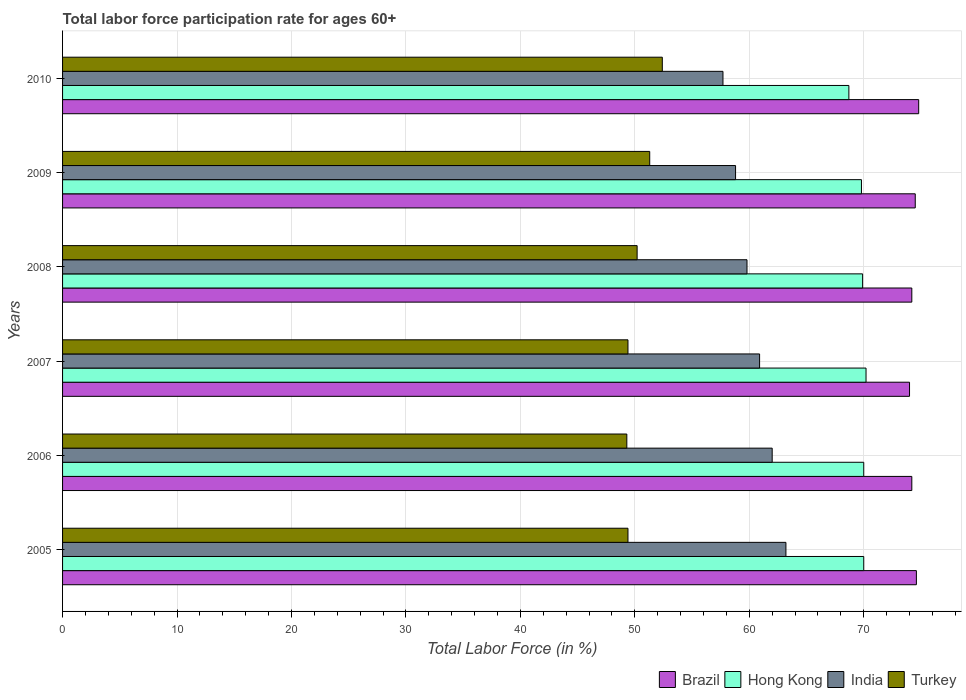How many groups of bars are there?
Your answer should be very brief. 6. Are the number of bars per tick equal to the number of legend labels?
Provide a short and direct response. Yes. Are the number of bars on each tick of the Y-axis equal?
Keep it short and to the point. Yes. How many bars are there on the 3rd tick from the top?
Provide a succinct answer. 4. How many bars are there on the 2nd tick from the bottom?
Ensure brevity in your answer.  4. What is the label of the 6th group of bars from the top?
Provide a short and direct response. 2005. In how many cases, is the number of bars for a given year not equal to the number of legend labels?
Your response must be concise. 0. What is the labor force participation rate in Brazil in 2005?
Your answer should be very brief. 74.6. Across all years, what is the maximum labor force participation rate in Hong Kong?
Offer a very short reply. 70.2. Across all years, what is the minimum labor force participation rate in Turkey?
Your answer should be compact. 49.3. What is the total labor force participation rate in Hong Kong in the graph?
Keep it short and to the point. 418.6. What is the difference between the labor force participation rate in India in 2005 and that in 2006?
Offer a very short reply. 1.2. What is the difference between the labor force participation rate in Turkey in 2008 and the labor force participation rate in Brazil in 2007?
Your answer should be compact. -23.8. What is the average labor force participation rate in Turkey per year?
Provide a succinct answer. 50.33. In the year 2005, what is the difference between the labor force participation rate in Brazil and labor force participation rate in India?
Give a very brief answer. 11.4. In how many years, is the labor force participation rate in India greater than 64 %?
Your answer should be very brief. 0. What is the ratio of the labor force participation rate in Turkey in 2009 to that in 2010?
Offer a very short reply. 0.98. What is the difference between the highest and the second highest labor force participation rate in Hong Kong?
Ensure brevity in your answer.  0.2. In how many years, is the labor force participation rate in Brazil greater than the average labor force participation rate in Brazil taken over all years?
Make the answer very short. 3. What does the 2nd bar from the top in 2009 represents?
Offer a very short reply. India. What does the 4th bar from the bottom in 2005 represents?
Your response must be concise. Turkey. Is it the case that in every year, the sum of the labor force participation rate in Brazil and labor force participation rate in Turkey is greater than the labor force participation rate in Hong Kong?
Your answer should be very brief. Yes. How many bars are there?
Offer a very short reply. 24. Are all the bars in the graph horizontal?
Offer a very short reply. Yes. Does the graph contain any zero values?
Your response must be concise. No. Does the graph contain grids?
Your answer should be compact. Yes. What is the title of the graph?
Provide a succinct answer. Total labor force participation rate for ages 60+. Does "Nicaragua" appear as one of the legend labels in the graph?
Give a very brief answer. No. What is the Total Labor Force (in %) in Brazil in 2005?
Your answer should be compact. 74.6. What is the Total Labor Force (in %) of India in 2005?
Provide a succinct answer. 63.2. What is the Total Labor Force (in %) in Turkey in 2005?
Your answer should be very brief. 49.4. What is the Total Labor Force (in %) in Brazil in 2006?
Your answer should be compact. 74.2. What is the Total Labor Force (in %) of Turkey in 2006?
Offer a terse response. 49.3. What is the Total Labor Force (in %) of Brazil in 2007?
Give a very brief answer. 74. What is the Total Labor Force (in %) in Hong Kong in 2007?
Provide a succinct answer. 70.2. What is the Total Labor Force (in %) in India in 2007?
Offer a terse response. 60.9. What is the Total Labor Force (in %) of Turkey in 2007?
Your answer should be very brief. 49.4. What is the Total Labor Force (in %) in Brazil in 2008?
Ensure brevity in your answer.  74.2. What is the Total Labor Force (in %) in Hong Kong in 2008?
Provide a succinct answer. 69.9. What is the Total Labor Force (in %) of India in 2008?
Offer a terse response. 59.8. What is the Total Labor Force (in %) in Turkey in 2008?
Offer a very short reply. 50.2. What is the Total Labor Force (in %) in Brazil in 2009?
Make the answer very short. 74.5. What is the Total Labor Force (in %) of Hong Kong in 2009?
Provide a short and direct response. 69.8. What is the Total Labor Force (in %) in India in 2009?
Give a very brief answer. 58.8. What is the Total Labor Force (in %) of Turkey in 2009?
Offer a very short reply. 51.3. What is the Total Labor Force (in %) of Brazil in 2010?
Provide a succinct answer. 74.8. What is the Total Labor Force (in %) of Hong Kong in 2010?
Give a very brief answer. 68.7. What is the Total Labor Force (in %) in India in 2010?
Offer a terse response. 57.7. What is the Total Labor Force (in %) of Turkey in 2010?
Your answer should be very brief. 52.4. Across all years, what is the maximum Total Labor Force (in %) in Brazil?
Your answer should be compact. 74.8. Across all years, what is the maximum Total Labor Force (in %) in Hong Kong?
Give a very brief answer. 70.2. Across all years, what is the maximum Total Labor Force (in %) of India?
Ensure brevity in your answer.  63.2. Across all years, what is the maximum Total Labor Force (in %) of Turkey?
Your answer should be very brief. 52.4. Across all years, what is the minimum Total Labor Force (in %) in Hong Kong?
Make the answer very short. 68.7. Across all years, what is the minimum Total Labor Force (in %) of India?
Your response must be concise. 57.7. Across all years, what is the minimum Total Labor Force (in %) of Turkey?
Your answer should be very brief. 49.3. What is the total Total Labor Force (in %) of Brazil in the graph?
Provide a succinct answer. 446.3. What is the total Total Labor Force (in %) of Hong Kong in the graph?
Your response must be concise. 418.6. What is the total Total Labor Force (in %) in India in the graph?
Make the answer very short. 362.4. What is the total Total Labor Force (in %) in Turkey in the graph?
Make the answer very short. 302. What is the difference between the Total Labor Force (in %) in Brazil in 2005 and that in 2006?
Provide a succinct answer. 0.4. What is the difference between the Total Labor Force (in %) in Brazil in 2005 and that in 2007?
Your answer should be compact. 0.6. What is the difference between the Total Labor Force (in %) of India in 2005 and that in 2007?
Ensure brevity in your answer.  2.3. What is the difference between the Total Labor Force (in %) in Brazil in 2005 and that in 2008?
Your answer should be compact. 0.4. What is the difference between the Total Labor Force (in %) of India in 2005 and that in 2008?
Your answer should be compact. 3.4. What is the difference between the Total Labor Force (in %) in Turkey in 2005 and that in 2009?
Your response must be concise. -1.9. What is the difference between the Total Labor Force (in %) in Brazil in 2005 and that in 2010?
Ensure brevity in your answer.  -0.2. What is the difference between the Total Labor Force (in %) in Hong Kong in 2005 and that in 2010?
Make the answer very short. 1.3. What is the difference between the Total Labor Force (in %) in Hong Kong in 2006 and that in 2007?
Your answer should be very brief. -0.2. What is the difference between the Total Labor Force (in %) in India in 2006 and that in 2007?
Your answer should be very brief. 1.1. What is the difference between the Total Labor Force (in %) in Turkey in 2006 and that in 2007?
Offer a very short reply. -0.1. What is the difference between the Total Labor Force (in %) in Brazil in 2006 and that in 2008?
Your response must be concise. 0. What is the difference between the Total Labor Force (in %) in Turkey in 2006 and that in 2008?
Keep it short and to the point. -0.9. What is the difference between the Total Labor Force (in %) of Brazil in 2006 and that in 2009?
Offer a terse response. -0.3. What is the difference between the Total Labor Force (in %) in India in 2006 and that in 2009?
Your answer should be compact. 3.2. What is the difference between the Total Labor Force (in %) of Turkey in 2006 and that in 2010?
Ensure brevity in your answer.  -3.1. What is the difference between the Total Labor Force (in %) of Hong Kong in 2007 and that in 2008?
Keep it short and to the point. 0.3. What is the difference between the Total Labor Force (in %) of India in 2007 and that in 2008?
Your response must be concise. 1.1. What is the difference between the Total Labor Force (in %) of Turkey in 2007 and that in 2008?
Provide a short and direct response. -0.8. What is the difference between the Total Labor Force (in %) in Brazil in 2007 and that in 2009?
Your answer should be very brief. -0.5. What is the difference between the Total Labor Force (in %) of India in 2007 and that in 2009?
Ensure brevity in your answer.  2.1. What is the difference between the Total Labor Force (in %) in Brazil in 2007 and that in 2010?
Make the answer very short. -0.8. What is the difference between the Total Labor Force (in %) in India in 2007 and that in 2010?
Your answer should be compact. 3.2. What is the difference between the Total Labor Force (in %) of Hong Kong in 2008 and that in 2009?
Offer a terse response. 0.1. What is the difference between the Total Labor Force (in %) in Brazil in 2008 and that in 2010?
Offer a terse response. -0.6. What is the difference between the Total Labor Force (in %) in Hong Kong in 2008 and that in 2010?
Offer a very short reply. 1.2. What is the difference between the Total Labor Force (in %) of India in 2008 and that in 2010?
Provide a short and direct response. 2.1. What is the difference between the Total Labor Force (in %) of Hong Kong in 2009 and that in 2010?
Keep it short and to the point. 1.1. What is the difference between the Total Labor Force (in %) of India in 2009 and that in 2010?
Ensure brevity in your answer.  1.1. What is the difference between the Total Labor Force (in %) of Brazil in 2005 and the Total Labor Force (in %) of Hong Kong in 2006?
Ensure brevity in your answer.  4.6. What is the difference between the Total Labor Force (in %) in Brazil in 2005 and the Total Labor Force (in %) in India in 2006?
Give a very brief answer. 12.6. What is the difference between the Total Labor Force (in %) of Brazil in 2005 and the Total Labor Force (in %) of Turkey in 2006?
Your response must be concise. 25.3. What is the difference between the Total Labor Force (in %) of Hong Kong in 2005 and the Total Labor Force (in %) of India in 2006?
Offer a terse response. 8. What is the difference between the Total Labor Force (in %) of Hong Kong in 2005 and the Total Labor Force (in %) of Turkey in 2006?
Your response must be concise. 20.7. What is the difference between the Total Labor Force (in %) in India in 2005 and the Total Labor Force (in %) in Turkey in 2006?
Your answer should be very brief. 13.9. What is the difference between the Total Labor Force (in %) in Brazil in 2005 and the Total Labor Force (in %) in Hong Kong in 2007?
Give a very brief answer. 4.4. What is the difference between the Total Labor Force (in %) in Brazil in 2005 and the Total Labor Force (in %) in India in 2007?
Your answer should be compact. 13.7. What is the difference between the Total Labor Force (in %) of Brazil in 2005 and the Total Labor Force (in %) of Turkey in 2007?
Keep it short and to the point. 25.2. What is the difference between the Total Labor Force (in %) of Hong Kong in 2005 and the Total Labor Force (in %) of India in 2007?
Your response must be concise. 9.1. What is the difference between the Total Labor Force (in %) of Hong Kong in 2005 and the Total Labor Force (in %) of Turkey in 2007?
Offer a very short reply. 20.6. What is the difference between the Total Labor Force (in %) in Brazil in 2005 and the Total Labor Force (in %) in Hong Kong in 2008?
Your response must be concise. 4.7. What is the difference between the Total Labor Force (in %) of Brazil in 2005 and the Total Labor Force (in %) of Turkey in 2008?
Your response must be concise. 24.4. What is the difference between the Total Labor Force (in %) of Hong Kong in 2005 and the Total Labor Force (in %) of Turkey in 2008?
Make the answer very short. 19.8. What is the difference between the Total Labor Force (in %) in India in 2005 and the Total Labor Force (in %) in Turkey in 2008?
Offer a terse response. 13. What is the difference between the Total Labor Force (in %) in Brazil in 2005 and the Total Labor Force (in %) in Hong Kong in 2009?
Keep it short and to the point. 4.8. What is the difference between the Total Labor Force (in %) of Brazil in 2005 and the Total Labor Force (in %) of Turkey in 2009?
Give a very brief answer. 23.3. What is the difference between the Total Labor Force (in %) of Hong Kong in 2005 and the Total Labor Force (in %) of India in 2009?
Make the answer very short. 11.2. What is the difference between the Total Labor Force (in %) of Hong Kong in 2005 and the Total Labor Force (in %) of Turkey in 2009?
Provide a short and direct response. 18.7. What is the difference between the Total Labor Force (in %) in India in 2005 and the Total Labor Force (in %) in Turkey in 2009?
Your answer should be compact. 11.9. What is the difference between the Total Labor Force (in %) of Brazil in 2005 and the Total Labor Force (in %) of Hong Kong in 2010?
Ensure brevity in your answer.  5.9. What is the difference between the Total Labor Force (in %) of Brazil in 2005 and the Total Labor Force (in %) of India in 2010?
Your answer should be compact. 16.9. What is the difference between the Total Labor Force (in %) of Brazil in 2005 and the Total Labor Force (in %) of Turkey in 2010?
Provide a short and direct response. 22.2. What is the difference between the Total Labor Force (in %) of Hong Kong in 2005 and the Total Labor Force (in %) of India in 2010?
Keep it short and to the point. 12.3. What is the difference between the Total Labor Force (in %) in Brazil in 2006 and the Total Labor Force (in %) in Hong Kong in 2007?
Ensure brevity in your answer.  4. What is the difference between the Total Labor Force (in %) in Brazil in 2006 and the Total Labor Force (in %) in Turkey in 2007?
Your response must be concise. 24.8. What is the difference between the Total Labor Force (in %) in Hong Kong in 2006 and the Total Labor Force (in %) in Turkey in 2007?
Provide a short and direct response. 20.6. What is the difference between the Total Labor Force (in %) of Brazil in 2006 and the Total Labor Force (in %) of Hong Kong in 2008?
Provide a succinct answer. 4.3. What is the difference between the Total Labor Force (in %) in Brazil in 2006 and the Total Labor Force (in %) in Turkey in 2008?
Your answer should be compact. 24. What is the difference between the Total Labor Force (in %) of Hong Kong in 2006 and the Total Labor Force (in %) of Turkey in 2008?
Your response must be concise. 19.8. What is the difference between the Total Labor Force (in %) of Brazil in 2006 and the Total Labor Force (in %) of India in 2009?
Give a very brief answer. 15.4. What is the difference between the Total Labor Force (in %) of Brazil in 2006 and the Total Labor Force (in %) of Turkey in 2009?
Offer a terse response. 22.9. What is the difference between the Total Labor Force (in %) in India in 2006 and the Total Labor Force (in %) in Turkey in 2009?
Make the answer very short. 10.7. What is the difference between the Total Labor Force (in %) of Brazil in 2006 and the Total Labor Force (in %) of Turkey in 2010?
Provide a short and direct response. 21.8. What is the difference between the Total Labor Force (in %) of Hong Kong in 2006 and the Total Labor Force (in %) of India in 2010?
Your answer should be compact. 12.3. What is the difference between the Total Labor Force (in %) in Hong Kong in 2006 and the Total Labor Force (in %) in Turkey in 2010?
Provide a succinct answer. 17.6. What is the difference between the Total Labor Force (in %) in Brazil in 2007 and the Total Labor Force (in %) in Hong Kong in 2008?
Make the answer very short. 4.1. What is the difference between the Total Labor Force (in %) of Brazil in 2007 and the Total Labor Force (in %) of Turkey in 2008?
Your answer should be very brief. 23.8. What is the difference between the Total Labor Force (in %) of Hong Kong in 2007 and the Total Labor Force (in %) of India in 2008?
Your answer should be compact. 10.4. What is the difference between the Total Labor Force (in %) in India in 2007 and the Total Labor Force (in %) in Turkey in 2008?
Ensure brevity in your answer.  10.7. What is the difference between the Total Labor Force (in %) in Brazil in 2007 and the Total Labor Force (in %) in Hong Kong in 2009?
Your answer should be compact. 4.2. What is the difference between the Total Labor Force (in %) in Brazil in 2007 and the Total Labor Force (in %) in Turkey in 2009?
Ensure brevity in your answer.  22.7. What is the difference between the Total Labor Force (in %) of India in 2007 and the Total Labor Force (in %) of Turkey in 2009?
Ensure brevity in your answer.  9.6. What is the difference between the Total Labor Force (in %) in Brazil in 2007 and the Total Labor Force (in %) in Hong Kong in 2010?
Keep it short and to the point. 5.3. What is the difference between the Total Labor Force (in %) of Brazil in 2007 and the Total Labor Force (in %) of India in 2010?
Your response must be concise. 16.3. What is the difference between the Total Labor Force (in %) of Brazil in 2007 and the Total Labor Force (in %) of Turkey in 2010?
Offer a very short reply. 21.6. What is the difference between the Total Labor Force (in %) in Hong Kong in 2007 and the Total Labor Force (in %) in India in 2010?
Your answer should be very brief. 12.5. What is the difference between the Total Labor Force (in %) in Hong Kong in 2007 and the Total Labor Force (in %) in Turkey in 2010?
Offer a terse response. 17.8. What is the difference between the Total Labor Force (in %) of Brazil in 2008 and the Total Labor Force (in %) of Hong Kong in 2009?
Provide a succinct answer. 4.4. What is the difference between the Total Labor Force (in %) in Brazil in 2008 and the Total Labor Force (in %) in Turkey in 2009?
Offer a terse response. 22.9. What is the difference between the Total Labor Force (in %) in Hong Kong in 2008 and the Total Labor Force (in %) in Turkey in 2009?
Offer a terse response. 18.6. What is the difference between the Total Labor Force (in %) in Brazil in 2008 and the Total Labor Force (in %) in Hong Kong in 2010?
Give a very brief answer. 5.5. What is the difference between the Total Labor Force (in %) of Brazil in 2008 and the Total Labor Force (in %) of India in 2010?
Provide a succinct answer. 16.5. What is the difference between the Total Labor Force (in %) in Brazil in 2008 and the Total Labor Force (in %) in Turkey in 2010?
Keep it short and to the point. 21.8. What is the difference between the Total Labor Force (in %) in Hong Kong in 2008 and the Total Labor Force (in %) in India in 2010?
Offer a terse response. 12.2. What is the difference between the Total Labor Force (in %) in Hong Kong in 2008 and the Total Labor Force (in %) in Turkey in 2010?
Keep it short and to the point. 17.5. What is the difference between the Total Labor Force (in %) of Brazil in 2009 and the Total Labor Force (in %) of Hong Kong in 2010?
Give a very brief answer. 5.8. What is the difference between the Total Labor Force (in %) in Brazil in 2009 and the Total Labor Force (in %) in Turkey in 2010?
Make the answer very short. 22.1. What is the difference between the Total Labor Force (in %) of India in 2009 and the Total Labor Force (in %) of Turkey in 2010?
Ensure brevity in your answer.  6.4. What is the average Total Labor Force (in %) of Brazil per year?
Make the answer very short. 74.38. What is the average Total Labor Force (in %) of Hong Kong per year?
Offer a very short reply. 69.77. What is the average Total Labor Force (in %) of India per year?
Give a very brief answer. 60.4. What is the average Total Labor Force (in %) of Turkey per year?
Offer a very short reply. 50.33. In the year 2005, what is the difference between the Total Labor Force (in %) in Brazil and Total Labor Force (in %) in Hong Kong?
Your answer should be very brief. 4.6. In the year 2005, what is the difference between the Total Labor Force (in %) in Brazil and Total Labor Force (in %) in Turkey?
Offer a terse response. 25.2. In the year 2005, what is the difference between the Total Labor Force (in %) in Hong Kong and Total Labor Force (in %) in India?
Your answer should be compact. 6.8. In the year 2005, what is the difference between the Total Labor Force (in %) of Hong Kong and Total Labor Force (in %) of Turkey?
Provide a succinct answer. 20.6. In the year 2006, what is the difference between the Total Labor Force (in %) in Brazil and Total Labor Force (in %) in Turkey?
Provide a succinct answer. 24.9. In the year 2006, what is the difference between the Total Labor Force (in %) in Hong Kong and Total Labor Force (in %) in Turkey?
Make the answer very short. 20.7. In the year 2006, what is the difference between the Total Labor Force (in %) in India and Total Labor Force (in %) in Turkey?
Offer a terse response. 12.7. In the year 2007, what is the difference between the Total Labor Force (in %) in Brazil and Total Labor Force (in %) in Hong Kong?
Provide a short and direct response. 3.8. In the year 2007, what is the difference between the Total Labor Force (in %) in Brazil and Total Labor Force (in %) in India?
Your answer should be very brief. 13.1. In the year 2007, what is the difference between the Total Labor Force (in %) in Brazil and Total Labor Force (in %) in Turkey?
Offer a terse response. 24.6. In the year 2007, what is the difference between the Total Labor Force (in %) of Hong Kong and Total Labor Force (in %) of India?
Provide a succinct answer. 9.3. In the year 2007, what is the difference between the Total Labor Force (in %) of Hong Kong and Total Labor Force (in %) of Turkey?
Ensure brevity in your answer.  20.8. In the year 2007, what is the difference between the Total Labor Force (in %) of India and Total Labor Force (in %) of Turkey?
Offer a terse response. 11.5. In the year 2008, what is the difference between the Total Labor Force (in %) of Brazil and Total Labor Force (in %) of India?
Your answer should be compact. 14.4. In the year 2008, what is the difference between the Total Labor Force (in %) in Hong Kong and Total Labor Force (in %) in India?
Offer a terse response. 10.1. In the year 2008, what is the difference between the Total Labor Force (in %) in India and Total Labor Force (in %) in Turkey?
Your response must be concise. 9.6. In the year 2009, what is the difference between the Total Labor Force (in %) in Brazil and Total Labor Force (in %) in Hong Kong?
Your answer should be compact. 4.7. In the year 2009, what is the difference between the Total Labor Force (in %) of Brazil and Total Labor Force (in %) of Turkey?
Offer a terse response. 23.2. In the year 2009, what is the difference between the Total Labor Force (in %) of India and Total Labor Force (in %) of Turkey?
Your response must be concise. 7.5. In the year 2010, what is the difference between the Total Labor Force (in %) in Brazil and Total Labor Force (in %) in Hong Kong?
Give a very brief answer. 6.1. In the year 2010, what is the difference between the Total Labor Force (in %) of Brazil and Total Labor Force (in %) of India?
Provide a short and direct response. 17.1. In the year 2010, what is the difference between the Total Labor Force (in %) of Brazil and Total Labor Force (in %) of Turkey?
Offer a terse response. 22.4. In the year 2010, what is the difference between the Total Labor Force (in %) of Hong Kong and Total Labor Force (in %) of India?
Offer a very short reply. 11. What is the ratio of the Total Labor Force (in %) of Brazil in 2005 to that in 2006?
Ensure brevity in your answer.  1.01. What is the ratio of the Total Labor Force (in %) of India in 2005 to that in 2006?
Make the answer very short. 1.02. What is the ratio of the Total Labor Force (in %) of India in 2005 to that in 2007?
Provide a succinct answer. 1.04. What is the ratio of the Total Labor Force (in %) in Brazil in 2005 to that in 2008?
Offer a very short reply. 1.01. What is the ratio of the Total Labor Force (in %) of India in 2005 to that in 2008?
Your answer should be compact. 1.06. What is the ratio of the Total Labor Force (in %) in Turkey in 2005 to that in 2008?
Offer a very short reply. 0.98. What is the ratio of the Total Labor Force (in %) of Hong Kong in 2005 to that in 2009?
Provide a succinct answer. 1. What is the ratio of the Total Labor Force (in %) in India in 2005 to that in 2009?
Give a very brief answer. 1.07. What is the ratio of the Total Labor Force (in %) in Brazil in 2005 to that in 2010?
Ensure brevity in your answer.  1. What is the ratio of the Total Labor Force (in %) of Hong Kong in 2005 to that in 2010?
Give a very brief answer. 1.02. What is the ratio of the Total Labor Force (in %) of India in 2005 to that in 2010?
Ensure brevity in your answer.  1.1. What is the ratio of the Total Labor Force (in %) in Turkey in 2005 to that in 2010?
Ensure brevity in your answer.  0.94. What is the ratio of the Total Labor Force (in %) of Hong Kong in 2006 to that in 2007?
Ensure brevity in your answer.  1. What is the ratio of the Total Labor Force (in %) of India in 2006 to that in 2007?
Your answer should be compact. 1.02. What is the ratio of the Total Labor Force (in %) of Turkey in 2006 to that in 2007?
Offer a very short reply. 1. What is the ratio of the Total Labor Force (in %) of Brazil in 2006 to that in 2008?
Your response must be concise. 1. What is the ratio of the Total Labor Force (in %) in Hong Kong in 2006 to that in 2008?
Offer a very short reply. 1. What is the ratio of the Total Labor Force (in %) in India in 2006 to that in 2008?
Your response must be concise. 1.04. What is the ratio of the Total Labor Force (in %) in Turkey in 2006 to that in 2008?
Offer a terse response. 0.98. What is the ratio of the Total Labor Force (in %) of Brazil in 2006 to that in 2009?
Your answer should be very brief. 1. What is the ratio of the Total Labor Force (in %) in Hong Kong in 2006 to that in 2009?
Your answer should be very brief. 1. What is the ratio of the Total Labor Force (in %) of India in 2006 to that in 2009?
Your response must be concise. 1.05. What is the ratio of the Total Labor Force (in %) of Turkey in 2006 to that in 2009?
Offer a very short reply. 0.96. What is the ratio of the Total Labor Force (in %) in Hong Kong in 2006 to that in 2010?
Offer a terse response. 1.02. What is the ratio of the Total Labor Force (in %) of India in 2006 to that in 2010?
Your answer should be very brief. 1.07. What is the ratio of the Total Labor Force (in %) in Turkey in 2006 to that in 2010?
Your answer should be very brief. 0.94. What is the ratio of the Total Labor Force (in %) in Brazil in 2007 to that in 2008?
Provide a short and direct response. 1. What is the ratio of the Total Labor Force (in %) of India in 2007 to that in 2008?
Offer a terse response. 1.02. What is the ratio of the Total Labor Force (in %) of Turkey in 2007 to that in 2008?
Your answer should be very brief. 0.98. What is the ratio of the Total Labor Force (in %) of Hong Kong in 2007 to that in 2009?
Offer a terse response. 1.01. What is the ratio of the Total Labor Force (in %) in India in 2007 to that in 2009?
Ensure brevity in your answer.  1.04. What is the ratio of the Total Labor Force (in %) of Brazil in 2007 to that in 2010?
Provide a short and direct response. 0.99. What is the ratio of the Total Labor Force (in %) in Hong Kong in 2007 to that in 2010?
Provide a short and direct response. 1.02. What is the ratio of the Total Labor Force (in %) in India in 2007 to that in 2010?
Make the answer very short. 1.06. What is the ratio of the Total Labor Force (in %) in Turkey in 2007 to that in 2010?
Offer a terse response. 0.94. What is the ratio of the Total Labor Force (in %) in Brazil in 2008 to that in 2009?
Offer a very short reply. 1. What is the ratio of the Total Labor Force (in %) in Turkey in 2008 to that in 2009?
Ensure brevity in your answer.  0.98. What is the ratio of the Total Labor Force (in %) in Brazil in 2008 to that in 2010?
Ensure brevity in your answer.  0.99. What is the ratio of the Total Labor Force (in %) in Hong Kong in 2008 to that in 2010?
Provide a succinct answer. 1.02. What is the ratio of the Total Labor Force (in %) in India in 2008 to that in 2010?
Your answer should be compact. 1.04. What is the ratio of the Total Labor Force (in %) of Turkey in 2008 to that in 2010?
Your answer should be very brief. 0.96. What is the ratio of the Total Labor Force (in %) in Hong Kong in 2009 to that in 2010?
Provide a short and direct response. 1.02. What is the ratio of the Total Labor Force (in %) in India in 2009 to that in 2010?
Ensure brevity in your answer.  1.02. What is the ratio of the Total Labor Force (in %) in Turkey in 2009 to that in 2010?
Make the answer very short. 0.98. What is the difference between the highest and the second highest Total Labor Force (in %) of Brazil?
Offer a very short reply. 0.2. What is the difference between the highest and the second highest Total Labor Force (in %) of Turkey?
Provide a succinct answer. 1.1. What is the difference between the highest and the lowest Total Labor Force (in %) in Turkey?
Give a very brief answer. 3.1. 